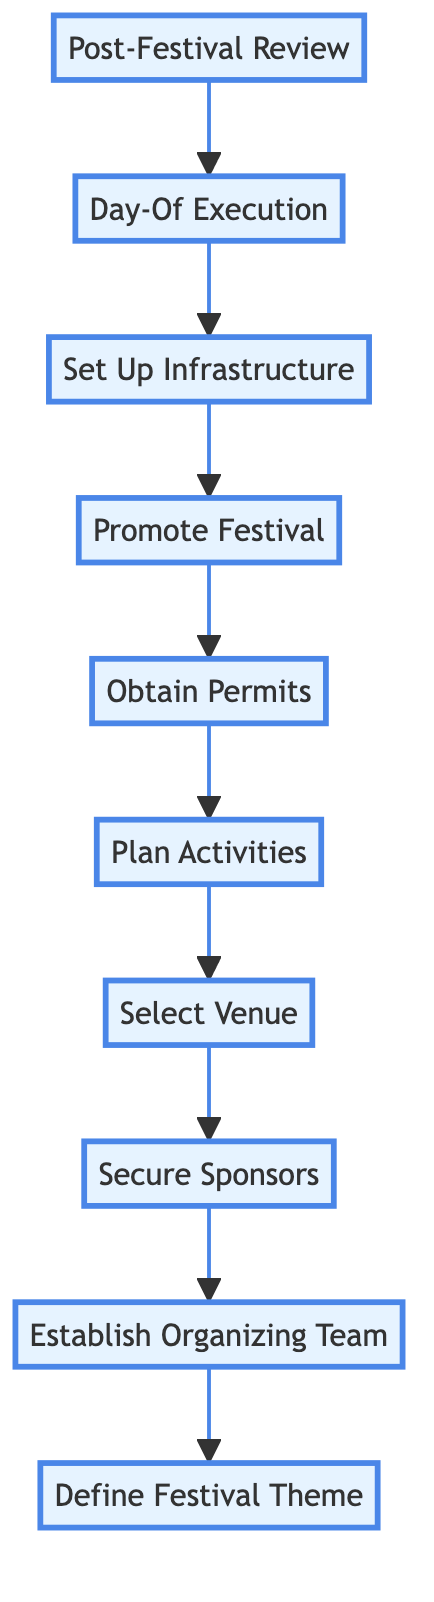What is the first step in the festival organization process? The flowchart shows that the first step is at the bottom, labeled "Define Festival Theme." This indicates it is the initial action taken to start the festival organization.
Answer: Define Festival Theme How many steps are in the flowchart? By counting the numbered steps listed in the flowchart from bottom to top, there are a total of ten distinct steps outlined.
Answer: 10 Which step comes directly before "Promote Festival"? The flowchart has "Obtain Permits" leading directly into "Promote Festival." Thus, "Obtain Permits" is the step that comes immediately before it.
Answer: Obtain Permits What occurs after the "Set Up Infrastructure" step? The arrow from "Set Up Infrastructure" points directly to "Day-Of Execution," indicating that this is the next step to be taken in the process.
Answer: Day-Of Execution Which two steps involve securing resources for the festival? The steps that pertain to securing resources are "Secure Sponsors" and "Obtain Permits." Both steps deal with obtaining necessary support and authorization for the festival.
Answer: Secure Sponsors and Obtain Permits Is "Promote Festival" before or after "Plan Activities"? In the flowchart, "Plan Activities" precedes "Promote Festival," showing that planning comes first before any promotional efforts are made.
Answer: Before What is the last step in the festival organization process? The last step, which is positioned at the very top of the chart, is labeled "Post-Festival Review," indicating it is the final action taken once the event concludes.
Answer: Post-Festival Review What steps relate specifically to the preparation of the festival venue? The steps that relate to the venue preparation are "Select Venue" and "Set Up Infrastructure." Both steps focus on choosing and preparing the location for the festival.
Answer: Select Venue and Set Up Infrastructure What element connects "Establish Organizing Team" and "Secure Sponsors"? The connection is a direct arrow leading from "Establish Organizing Team" to "Secure Sponsors," indicating that forming the team precedes seeking sponsorship.
Answer: An arrow 